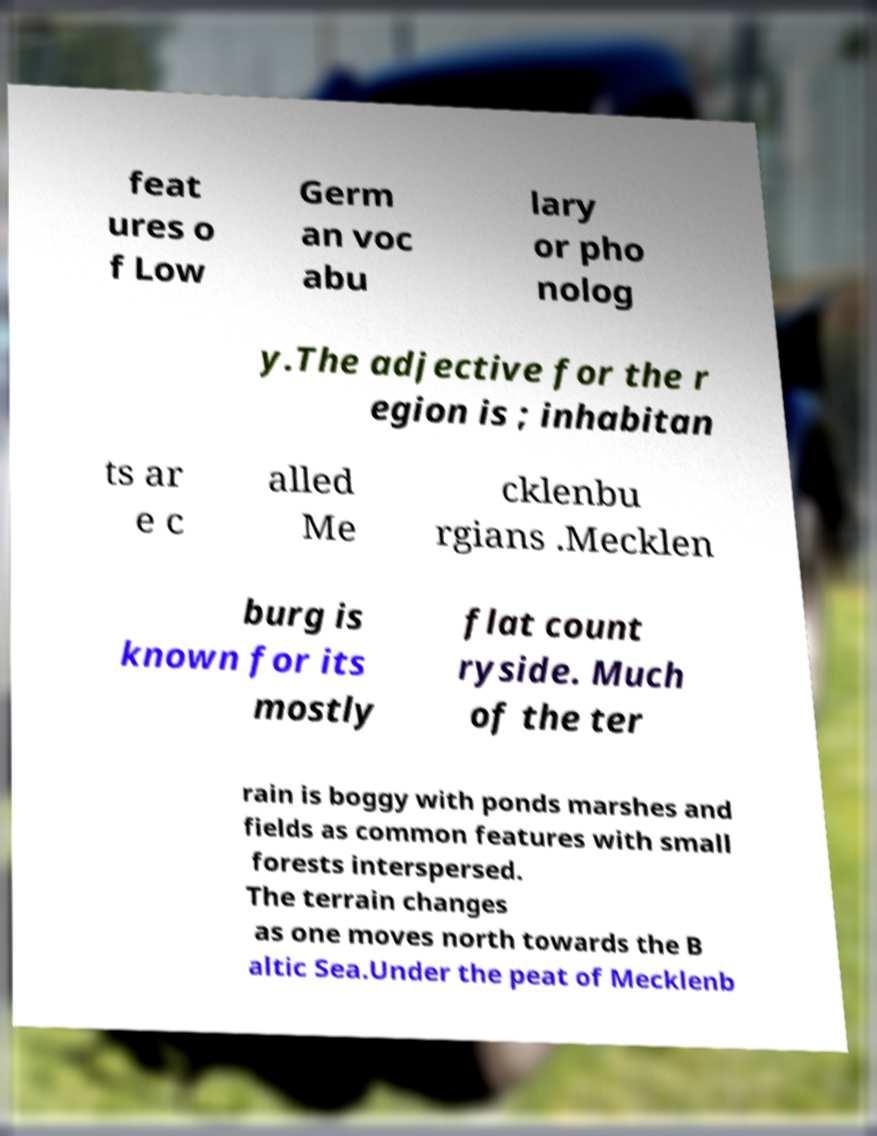For documentation purposes, I need the text within this image transcribed. Could you provide that? feat ures o f Low Germ an voc abu lary or pho nolog y.The adjective for the r egion is ; inhabitan ts ar e c alled Me cklenbu rgians .Mecklen burg is known for its mostly flat count ryside. Much of the ter rain is boggy with ponds marshes and fields as common features with small forests interspersed. The terrain changes as one moves north towards the B altic Sea.Under the peat of Mecklenb 